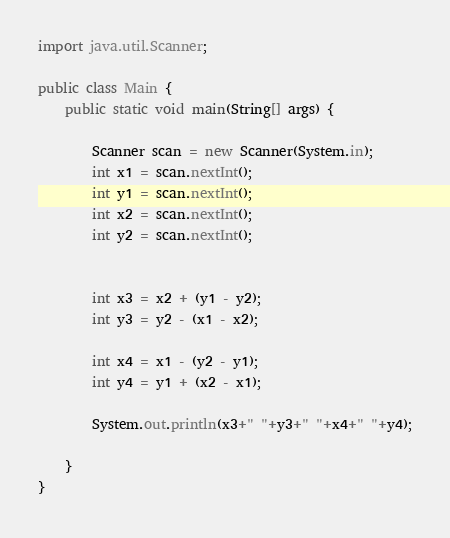Convert code to text. <code><loc_0><loc_0><loc_500><loc_500><_Java_>import java.util.Scanner;

public class Main {
	public static void main(String[] args) {
		
		Scanner scan = new Scanner(System.in);
		int x1 = scan.nextInt();
		int y1 = scan.nextInt();
		int x2 = scan.nextInt();
		int y2 = scan.nextInt();
		
		
		int x3 = x2 + (y1 - y2);
		int y3 = y2 - (x1 - x2);
		
		int x4 = x1 - (y2 - y1);
		int y4 = y1 + (x2 - x1);
		
		System.out.println(x3+" "+y3+" "+x4+" "+y4);
		
	}
}
</code> 